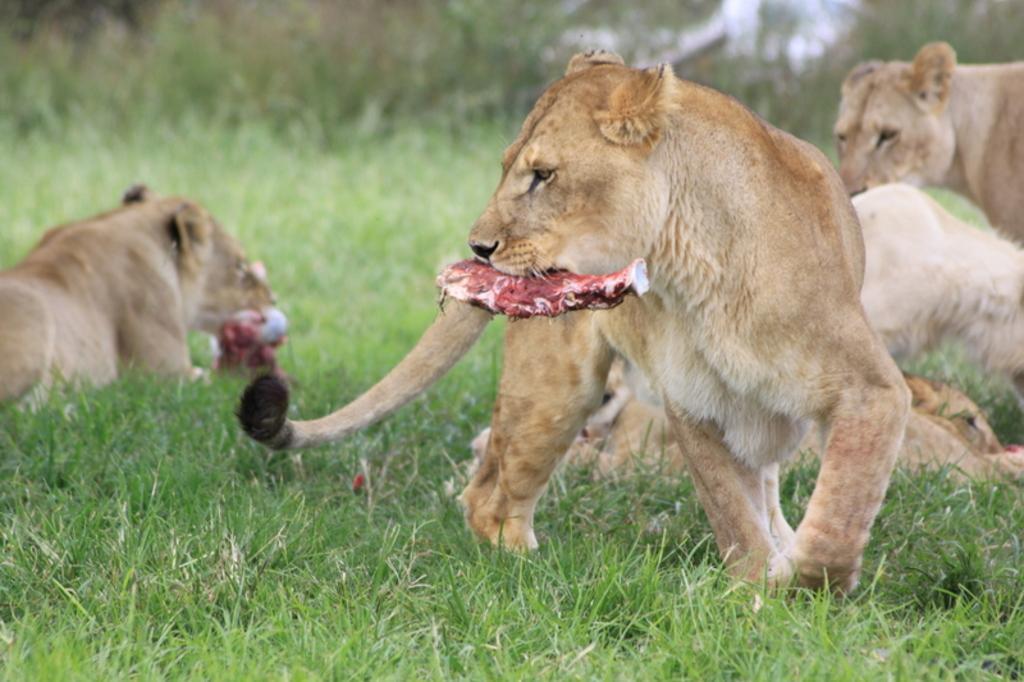Please provide a concise description of this image. In this image I see a lion which is on the grass and it has meat in the mouth. In the background I see few lions. 